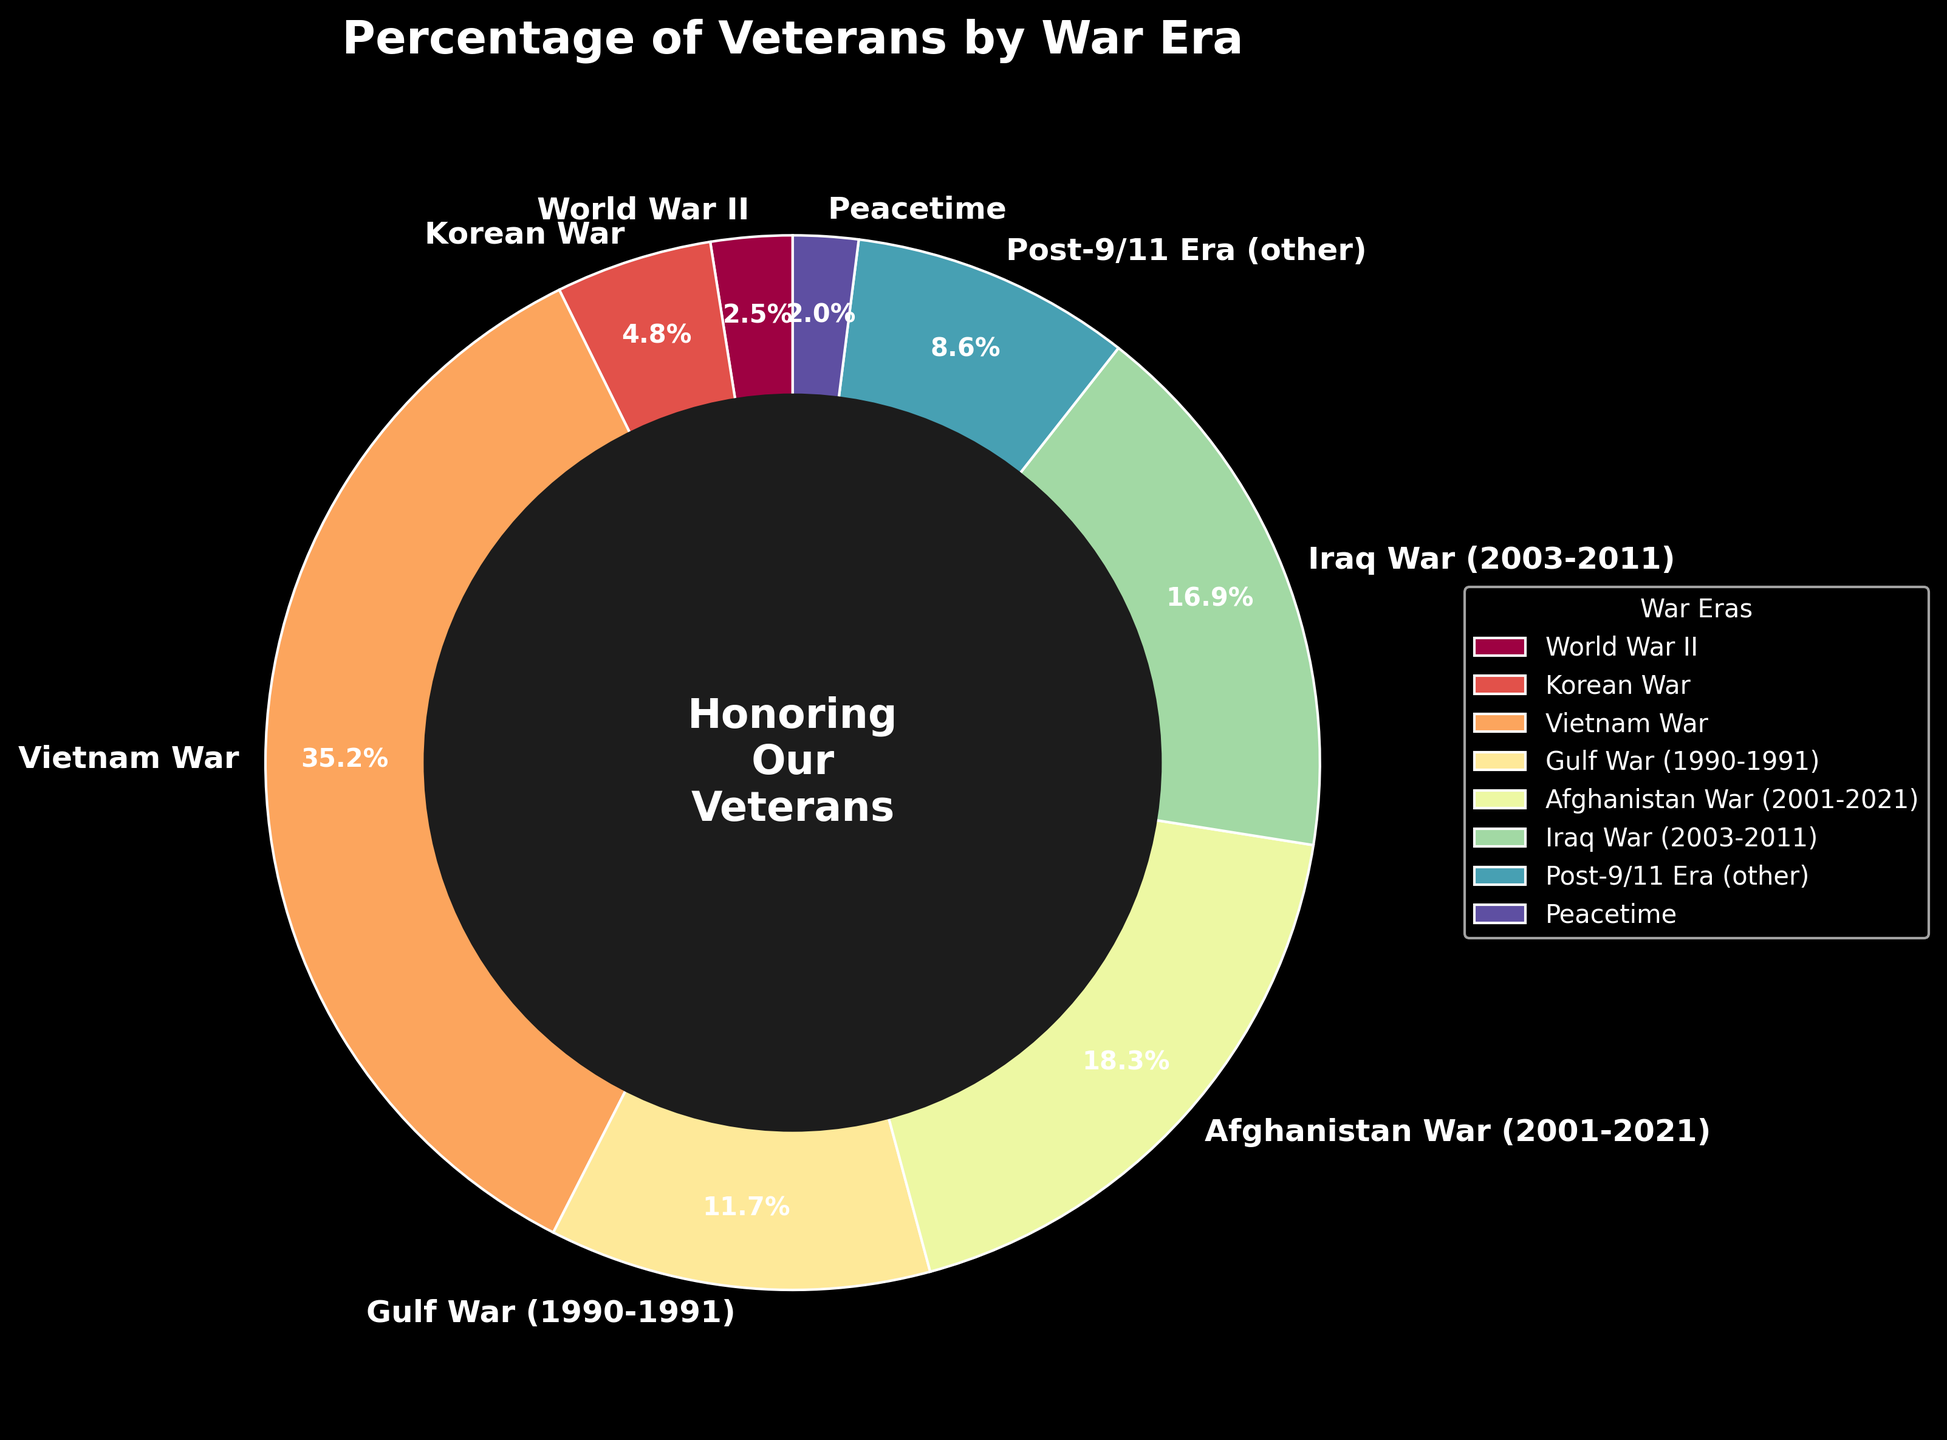What percentage of veterans served in the Vietnam War? To determine the percentage of veterans who served in the Vietnam War, find the slice labeled "Vietnam War" and read its percentage.
Answer: 35.2% Which war era has more veterans: Gulf War (1990-1991) or Iraq War (2003-2011)? To compare these two war eras, find their respective slices on the pie chart and compare the percentages. Gulf War (1990-1991) has 11.7% and Iraq War (2003-2011) has 16.9%. 16.9% is greater than 11.7%.
Answer: Iraq War (2003-2011) What is the combined percentage of veterans who served in the two most recent war eras shown (Afghanistan War and Post-9/11 Era)? Find the percentages for the Afghanistan War (18.3%) and Post-9/11 Era (8.6%) and add them together: 18.3% + 8.6% = 26.9%.
Answer: 26.9% Which war era has the smallest percentage of veterans? Find the slice with the smallest percentage by looking at all the slices. Peacetime has the smallest percentage at 2.0%.
Answer: Peacetime What is the difference in percentage between veterans of the Vietnam War and the Korean War? Find the percentages of the Vietnam War (35.2%) and Korean War (4.8%) and subtract the smaller from the larger: 35.2% - 4.8% = 30.4%.
Answer: 30.4% Is the percentage of veterans who served in the Gulf War (1990-1991) greater than the percentage of veterans who served in the World War II and Peacetime combined? First, find the combined percentage for World War II (2.5%) and Peacetime (2.0%): 2.5% + 2.0% = 4.5%. Then, compare it with the Gulf War (1990-1991) percentage (11.7%). 11.7% is greater than 4.5%.
Answer: Yes What is the total percentage of veterans who served in World War II, Korean War, and Peacetime? Find the percentages for World War II (2.5%), Korean War (4.8%), and Peacetime (2.0%) and add them together: 2.5% + 4.8% + 2.0% = 9.3%.
Answer: 9.3% Which war era has more veterans: Afghanistan War (2001-2021) or Post-9/11 Era (other)? Compare the percentages of the Afghanistan War (18.3%) with Post-9/11 Era (8.6%). 18.3% is greater than 8.6%.
Answer: Afghanistan War (2001-2021) What is the percentage difference between veterans of the Korean War and those of the Iraq War? Find the percentages of the Korean War (4.8%) and the Iraq War (16.9%) and subtract the smaller from the larger: 16.9% - 4.8% = 12.1%.
Answer: 12.1% What percentage of veterans served in the Vietnam War and Peacetime combined? Find the percentages for the Vietnam War (35.2%) and Peacetime (2.0%) and add them together: 35.2% + 2.0% = 37.2%.
Answer: 37.2% 